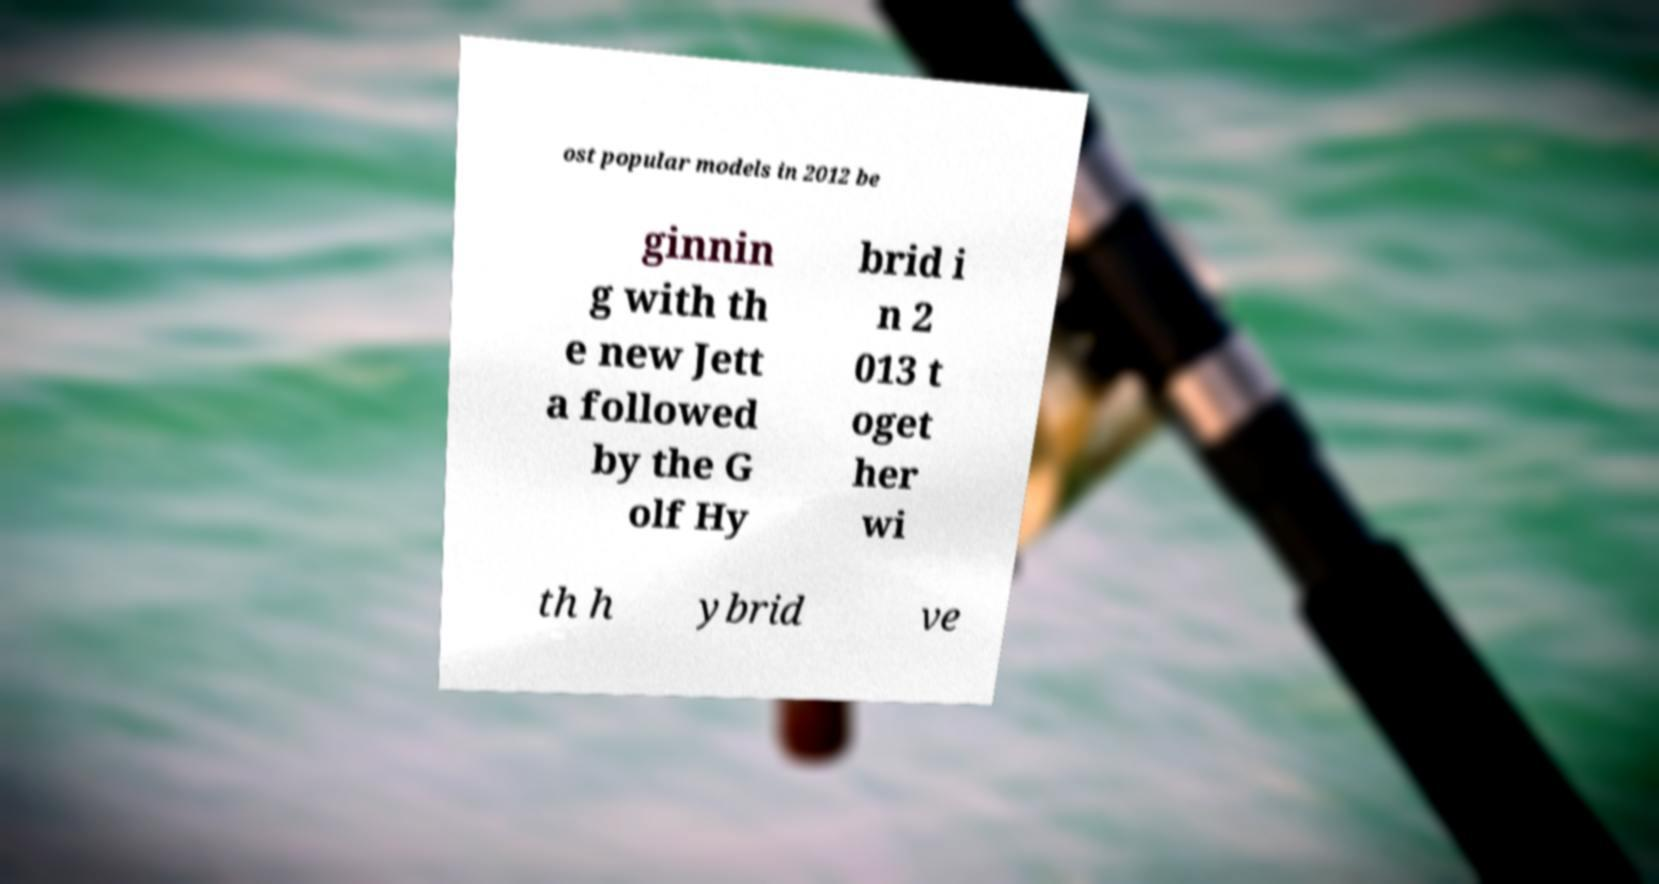Could you assist in decoding the text presented in this image and type it out clearly? ost popular models in 2012 be ginnin g with th e new Jett a followed by the G olf Hy brid i n 2 013 t oget her wi th h ybrid ve 